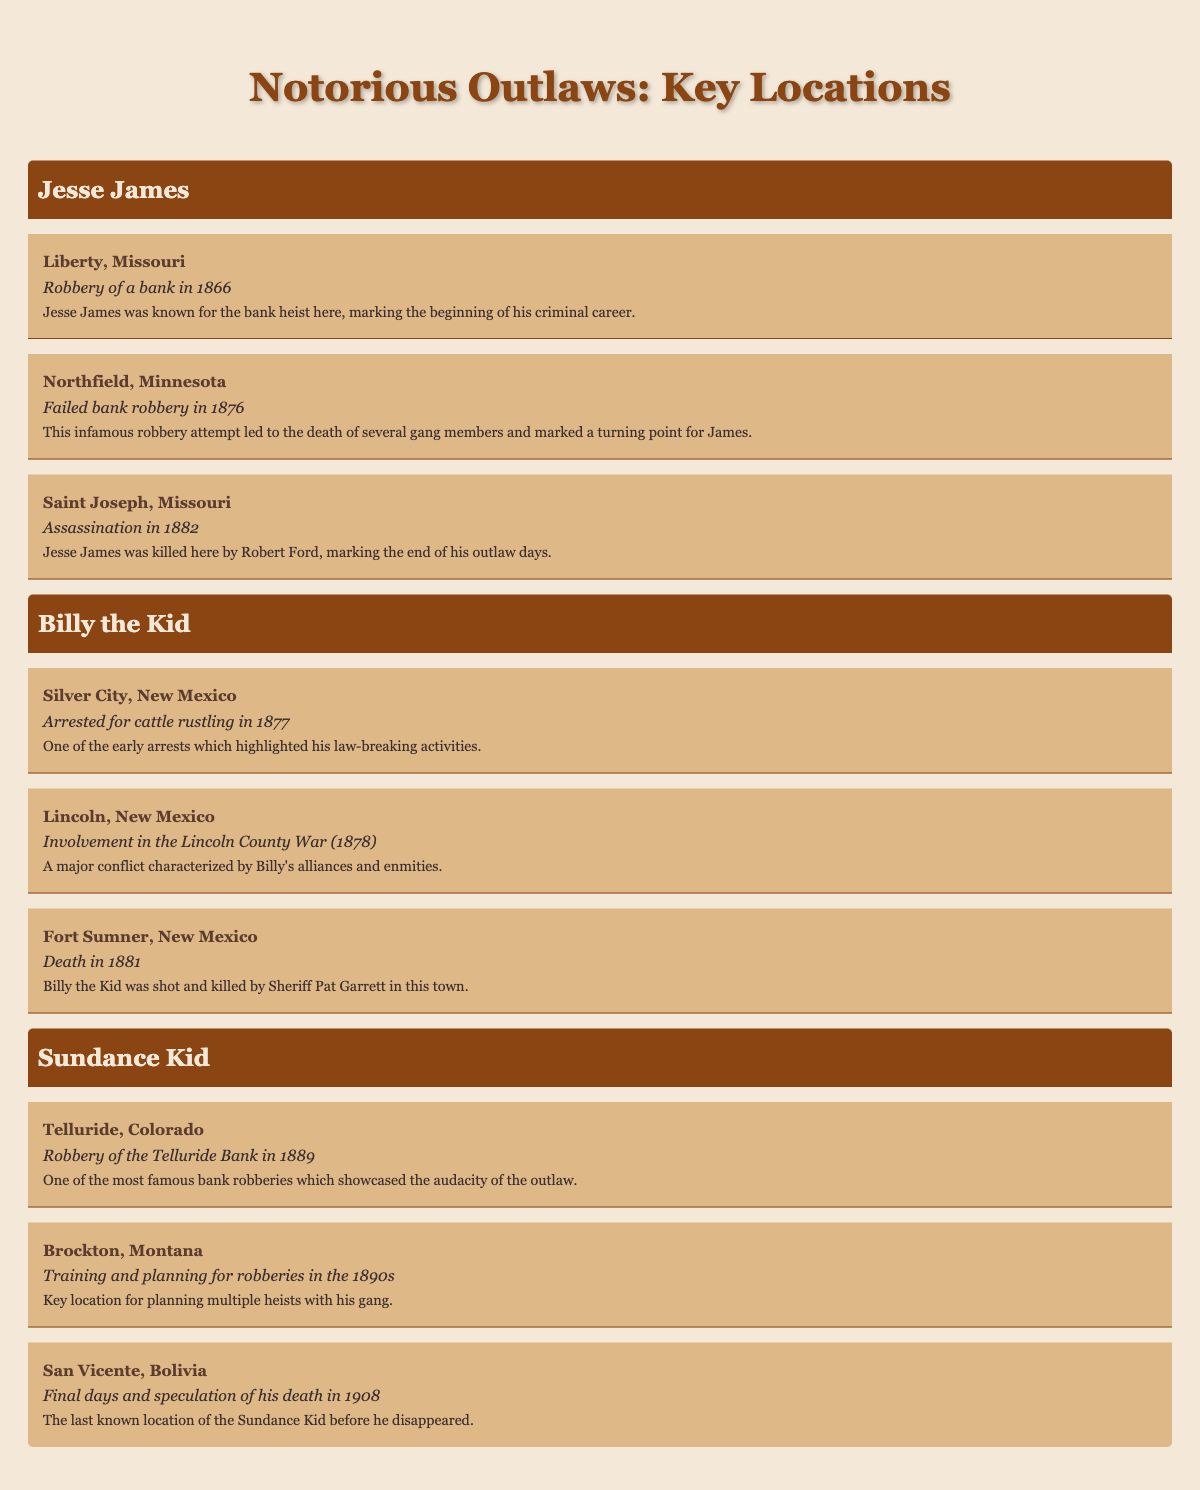What was the activity associated with Jesse James in Liberty, Missouri? The table indicates that in Liberty, Missouri, Jesse James was involved in a robbery of a bank in 1866.
Answer: Bank robbery in 1866 In which city was Billy the Kid involved in the Lincoln County War? According to the table, Billy the Kid was involved in the Lincoln County War in Lincoln, New Mexico in 1878.
Answer: Lincoln, New Mexico Did the Sundance Kid die in the United States? The table shows that the last known location of the Sundance Kid was San Vicente in Bolivia, suggesting that he did not die in the United States.
Answer: No Which outlaw was shot and killed by Sheriff Pat Garrett, and where did this happen? The table specifies that Billy the Kid was shot and killed by Sheriff Pat Garrett in Fort Sumner, New Mexico in 1881.
Answer: Billy the Kid in Fort Sumner, New Mexico What significant event occurred in Northfield, Minnesota related to Jesse James? The table highlights that Jesse James attempted a bank robbery in Northfield, Minnesota in 1876, which was significant due to its failure and the consequent deaths of gang members.
Answer: Failed bank robbery in 1876 How many different states are associated with Jesse James based on the table? The table lists three locations for Jesse James: Liberty (Missouri), Northfield (Minnesota), and Saint Joseph (Missouri). Since Missouri appears twice, the unique count of states is two.
Answer: Two states What was the activity listed for the Sundance Kid in Telluride, Colorado? The table indicates that in Telluride, Colorado, the Sundance Kid committed a robbery of the Telluride Bank in 1889.
Answer: Robbery of the Telluride Bank in 1889 Can you identify the last activity listed for Billy the Kid? According to the table, the last activity listed for Billy the Kid was his death in Fort Sumner, New Mexico in 1881.
Answer: Death in Fort Sumner, New Mexico in 1881 What was the significance of the assassination that took place in Saint Joseph, Missouri? The table describes the assassination of Jesse James by Robert Ford in Saint Joseph, Missouri in 1882 as significant because it marked the end of James's outlaw days.
Answer: Marked the end of his outlaw days 